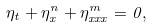<formula> <loc_0><loc_0><loc_500><loc_500>\eta _ { t } + \eta _ { x } ^ { n } + \eta _ { x x x } ^ { m } = 0 ,</formula> 